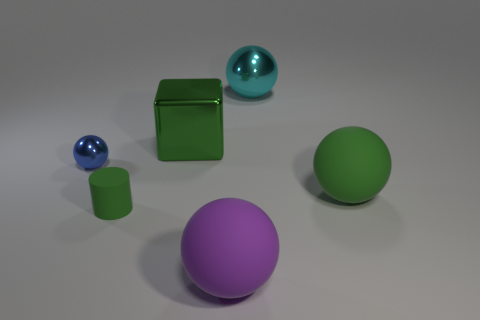There is a big thing that is in front of the cylinder; does it have the same shape as the cyan thing?
Provide a short and direct response. Yes. Are any large purple objects visible?
Provide a succinct answer. Yes. Is there anything else that is the same shape as the green metallic thing?
Give a very brief answer. No. Are there more green cylinders that are behind the large purple object than tiny purple matte spheres?
Your response must be concise. Yes. There is a blue ball; are there any balls to the right of it?
Ensure brevity in your answer.  Yes. Do the cylinder and the blue object have the same size?
Provide a succinct answer. Yes. What is the size of the purple matte object that is the same shape as the cyan metal object?
Offer a very short reply. Large. Is there anything else that has the same size as the cyan sphere?
Make the answer very short. Yes. There is a large ball behind the big green object that is to the right of the large cyan object; what is it made of?
Your answer should be very brief. Metal. Do the large purple thing and the cyan shiny object have the same shape?
Your response must be concise. Yes. 